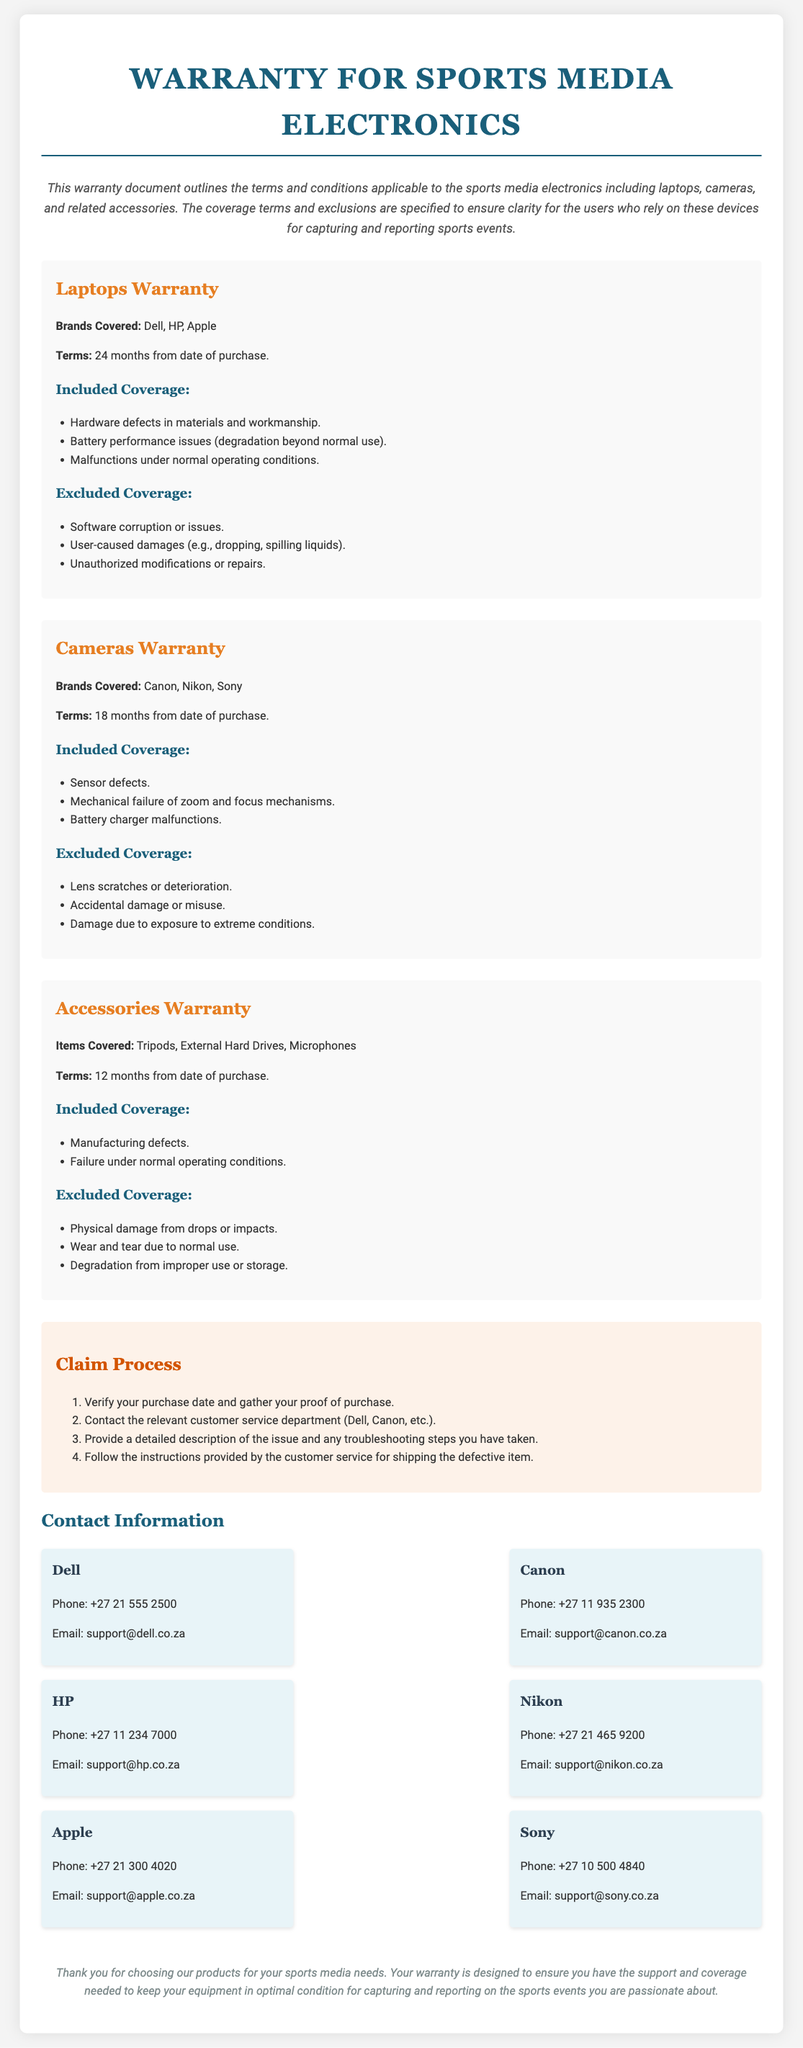What is the warranty term for laptops? The warranty term for laptops is specified as 24 months from the date of purchase.
Answer: 24 months Which brands are covered under the cameras warranty? The document lists Canon, Nikon, and Sony as the brands covered under the cameras warranty.
Answer: Canon, Nikon, Sony What types of items are covered under the accessories warranty? Accessories warranty covers tripods, external hard drives, and microphones.
Answer: Tripods, External Hard Drives, Microphones What is the first step in the claim process? The first step in the claim process is to verify the purchase date and gather proof of purchase.
Answer: Verify your purchase date and gather your proof of purchase Which damages are excluded from laptop warranty coverage? This section lists software corruption, user-caused damages, and unauthorized modifications as excluded coverage for laptops.
Answer: Software corruption or issues, User-caused damages, Unauthorized modifications How long is the warranty for cameras? The warranty for cameras is 18 months from the date of purchase.
Answer: 18 months What is covered under included coverage for accessories? Included coverage for accessories includes manufacturing defects and failure under normal operating conditions.
Answer: Manufacturing defects, Failure under normal operating conditions Which brand's customer service can be contacted at +27 21 300 4020? The document indicates that Apple's customer service can be contacted at this number.
Answer: Apple What kind of performance issues are included in the laptops warranty? The warranty includes battery performance issues, specifically regarding degradation beyond normal use.
Answer: Battery performance issues (degradation beyond normal use) 